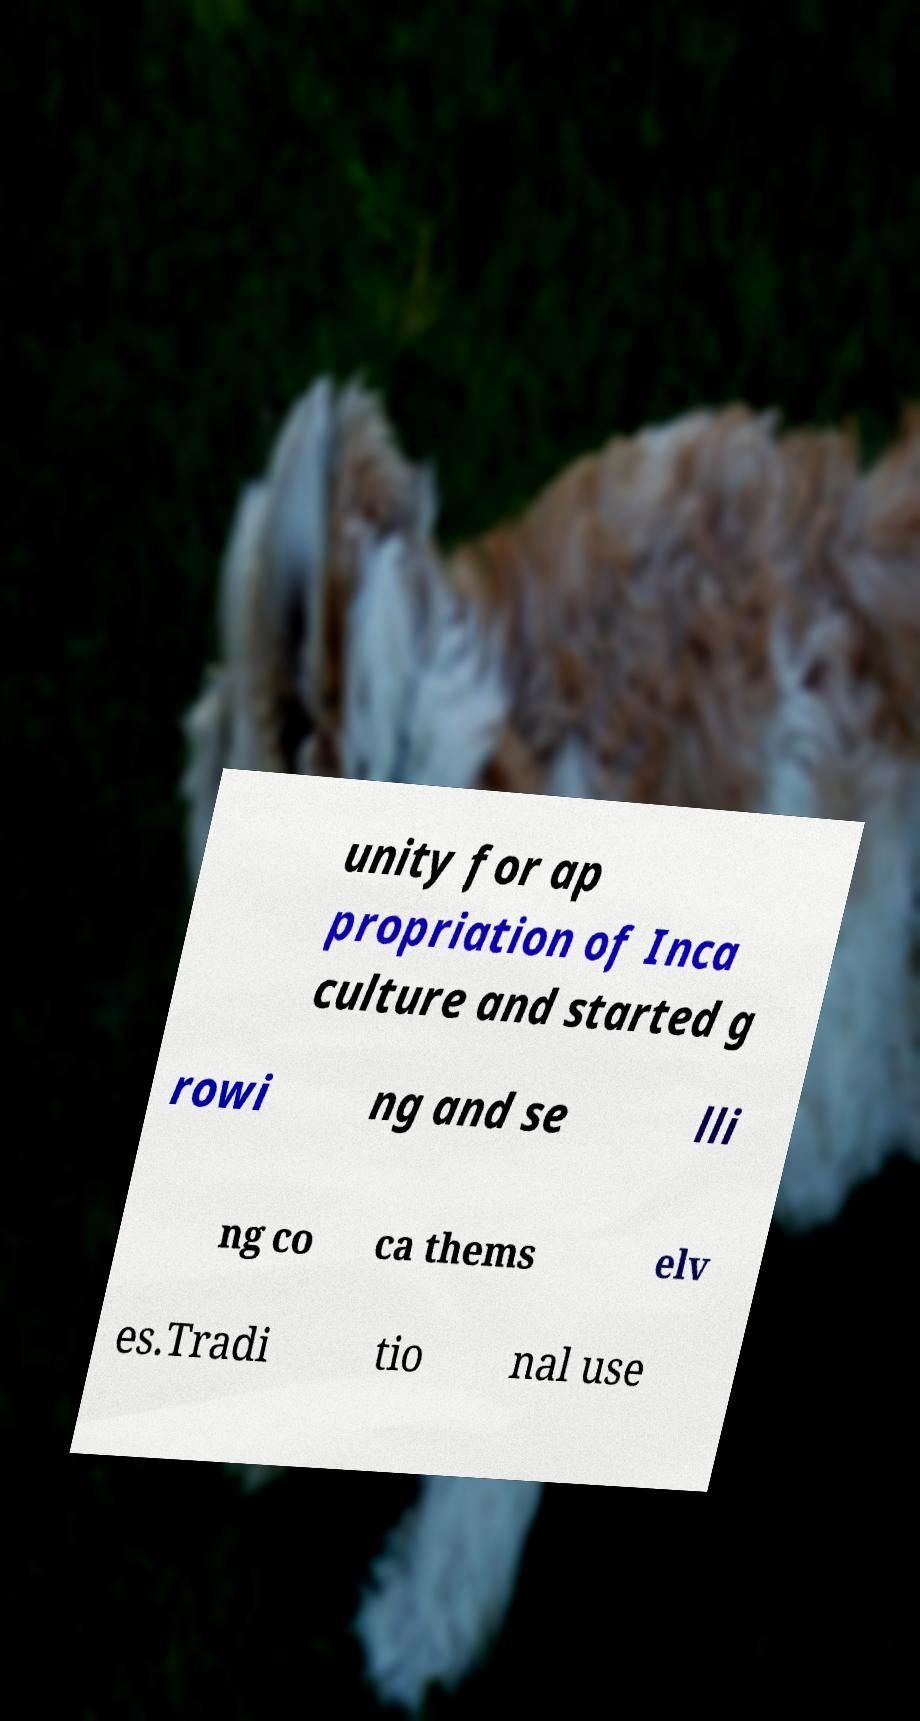For documentation purposes, I need the text within this image transcribed. Could you provide that? unity for ap propriation of Inca culture and started g rowi ng and se lli ng co ca thems elv es.Tradi tio nal use 